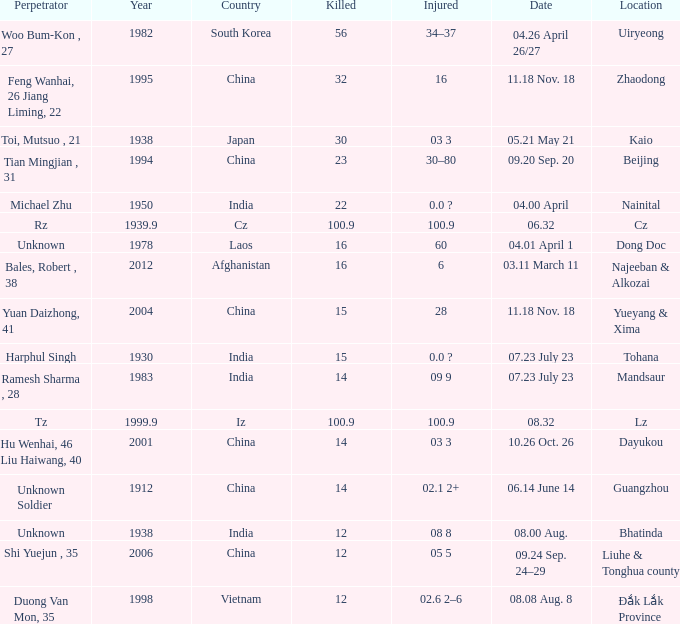Could you help me parse every detail presented in this table? {'header': ['Perpetrator', 'Year', 'Country', 'Killed', 'Injured', 'Date', 'Location'], 'rows': [['Woo Bum-Kon , 27', '1982', 'South Korea', '56', '34–37', '04.26 April 26/27', 'Uiryeong'], ['Feng Wanhai, 26 Jiang Liming, 22', '1995', 'China', '32', '16', '11.18 Nov. 18', 'Zhaodong'], ['Toi, Mutsuo , 21', '1938', 'Japan', '30', '03 3', '05.21 May 21', 'Kaio'], ['Tian Mingjian , 31', '1994', 'China', '23', '30–80', '09.20 Sep. 20', 'Beijing'], ['Michael Zhu', '1950', 'India', '22', '0.0 ?', '04.00 April', 'Nainital'], ['Rz', '1939.9', 'Cz', '100.9', '100.9', '06.32', 'Cz'], ['Unknown', '1978', 'Laos', '16', '60', '04.01 April 1', 'Dong Doc'], ['Bales, Robert , 38', '2012', 'Afghanistan', '16', '6', '03.11 March 11', 'Najeeban & Alkozai'], ['Yuan Daizhong, 41', '2004', 'China', '15', '28', '11.18 Nov. 18', 'Yueyang & Xima'], ['Harphul Singh', '1930', 'India', '15', '0.0 ?', '07.23 July 23', 'Tohana'], ['Ramesh Sharma , 28', '1983', 'India', '14', '09 9', '07.23 July 23', 'Mandsaur'], ['Tz', '1999.9', 'Iz', '100.9', '100.9', '08.32', 'Lz'], ['Hu Wenhai, 46 Liu Haiwang, 40', '2001', 'China', '14', '03 3', '10.26 Oct. 26', 'Dayukou'], ['Unknown Soldier', '1912', 'China', '14', '02.1 2+', '06.14 June 14', 'Guangzhou'], ['Unknown', '1938', 'India', '12', '08 8', '08.00 Aug.', 'Bhatinda'], ['Shi Yuejun , 35', '2006', 'China', '12', '05 5', '09.24 Sep. 24–29', 'Liuhe & Tonghua county'], ['Duong Van Mon, 35', '1998', 'Vietnam', '12', '02.6 2–6', '08.08 Aug. 8', 'Đắk Lắk Province']]} What is Date, when Country is "China", and when Perpetrator is "Shi Yuejun , 35"? 09.24 Sep. 24–29. 